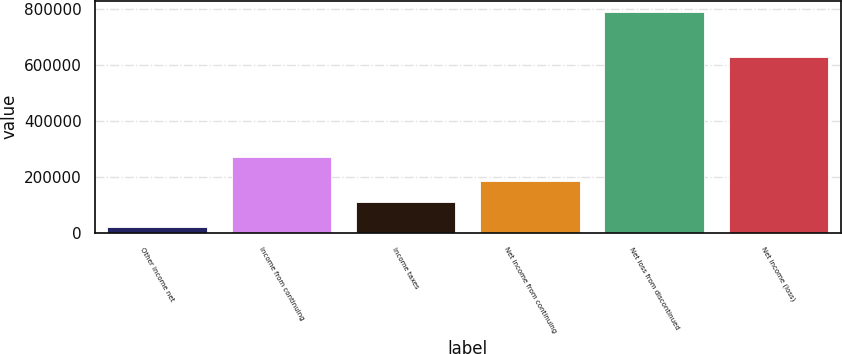Convert chart to OTSL. <chart><loc_0><loc_0><loc_500><loc_500><bar_chart><fcel>Other income net<fcel>Income from continuing<fcel>Income taxes<fcel>Net income from continuing<fcel>Net loss from discontinued<fcel>Net income (loss)<nl><fcel>19999<fcel>272175<fcel>109589<fcel>186675<fcel>790862<fcel>628276<nl></chart> 